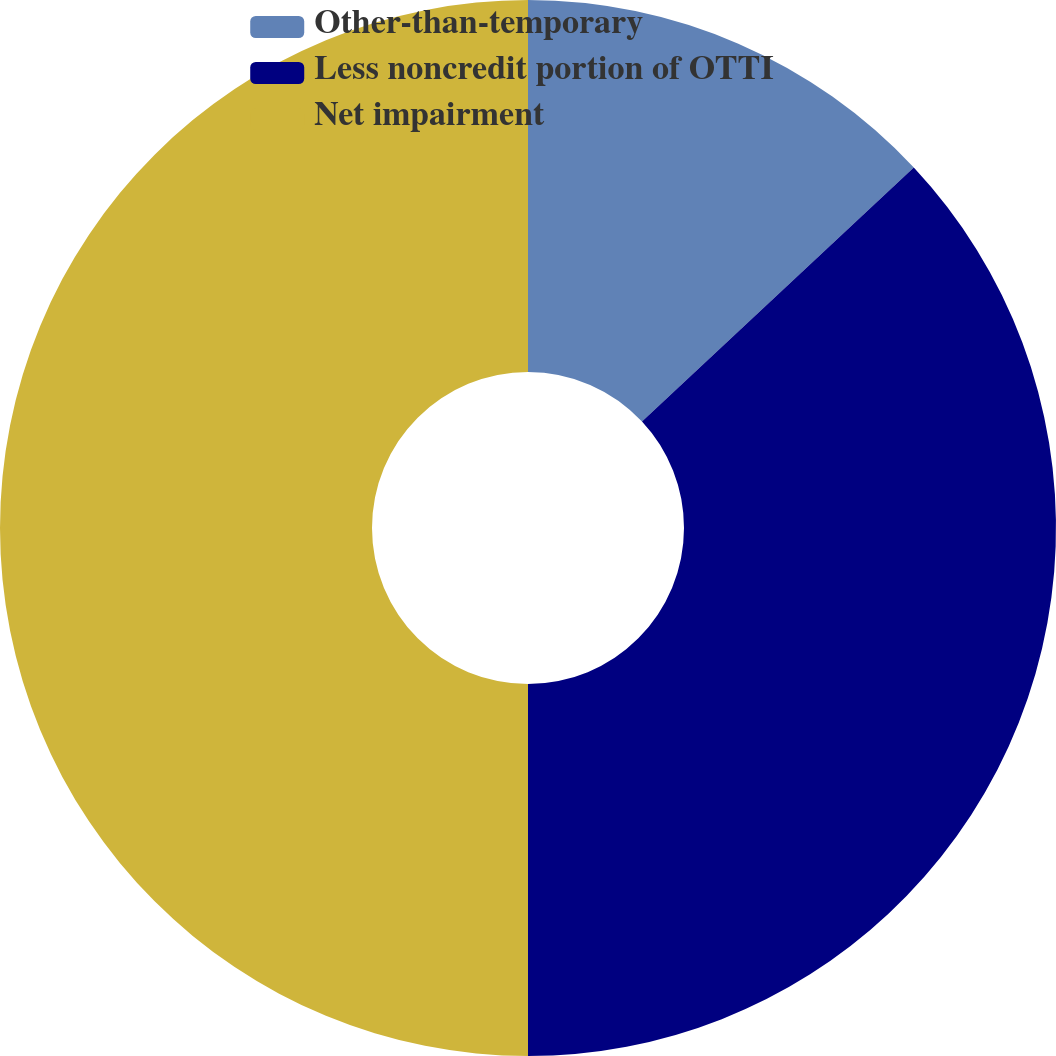<chart> <loc_0><loc_0><loc_500><loc_500><pie_chart><fcel>Other-than-temporary<fcel>Less noncredit portion of OTTI<fcel>Net impairment<nl><fcel>13.04%<fcel>36.96%<fcel>50.0%<nl></chart> 